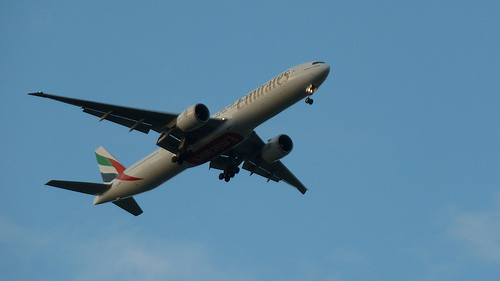What's the airplane in? The airplane is in mid-air, likely at a significant altitude as it navigates across the sky. 